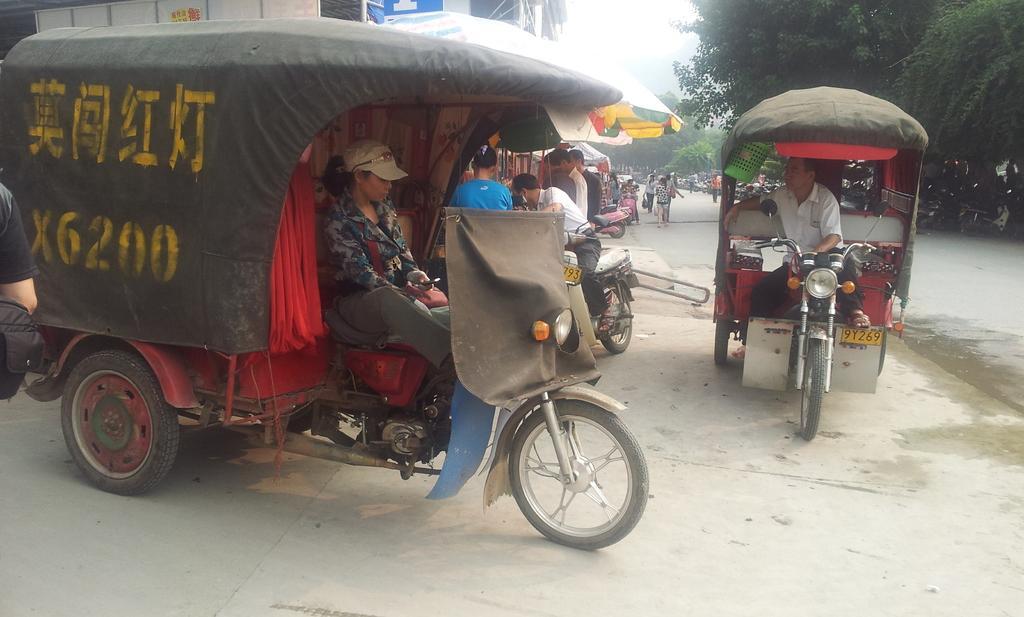In one or two sentences, can you explain what this image depicts? In this picture we can see a group of people, vehicles on the road, trees, umbrellas and some objects and in the background we can see the sky. 